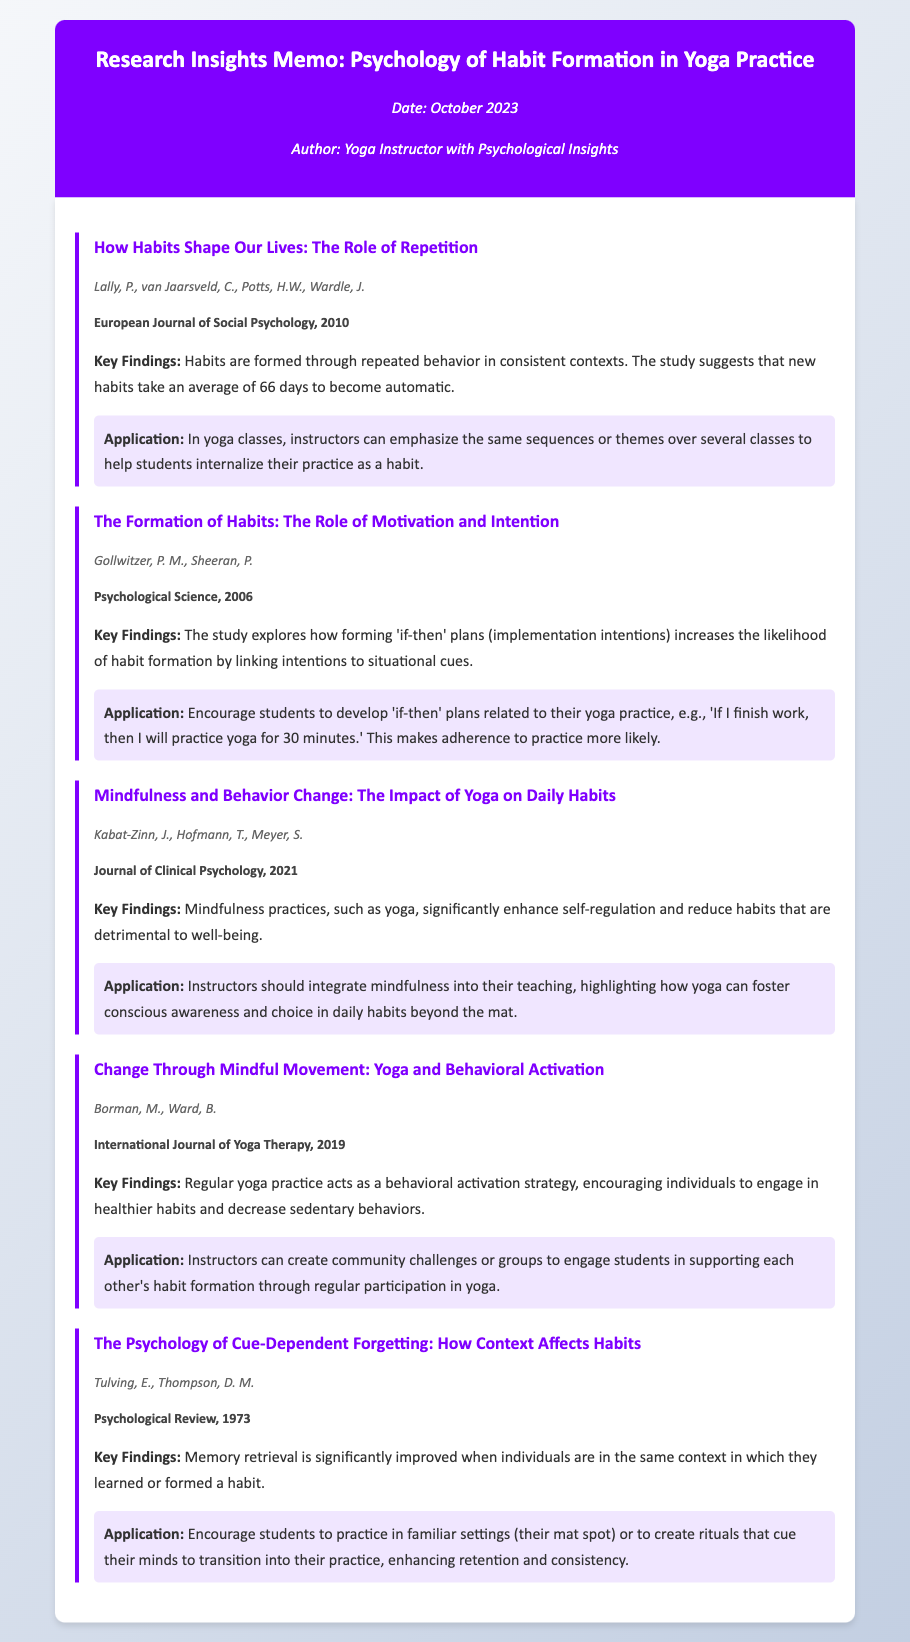What is the primary focus of this memo? The memo focuses on the psychology of habit formation as it relates to yoga practice, summarizing key findings from recent studies.
Answer: Psychology of habit formation in yoga practice Who are the authors of the first study mentioned? The first study titled "How Habits Shape Our Lives: The Role of Repetition" is authored by Lally, van Jaarsveld, Potts, and Wardle.
Answer: Lally, van Jaarsveld, Potts, Wardle What is the average number of days it takes to form a new habit according to the first study? The first study suggests that new habits take an average of 66 days to become automatic.
Answer: 66 days What type of plans are encouraged for habit formation in the second study? The second study suggests forming 'if-then' plans to enhance the likelihood of habit formation.
Answer: 'if-then' plans In what journal was the 2021 study published? The 2021 study titled "Mindfulness and Behavior Change: The Impact of Yoga on Daily Habits" was published in the Journal of Clinical Psychology.
Answer: Journal of Clinical Psychology What application is suggested from the findings of the last study? The last study advises encouraging students to practice in familiar settings to enhance retention and consistency.
Answer: Practice in familiar settings How does regular yoga practice benefit habits according to the fourth study? The fourth study indicates that regular yoga practice acts as a behavioral activation strategy, encouraging healthier habits.
Answer: Encouraging healthier habits What is the psychological concept addressed in the last study related to habit formation? The last study discusses cue-dependent forgetting and how context affects habits.
Answer: Cue-dependent forgetting 